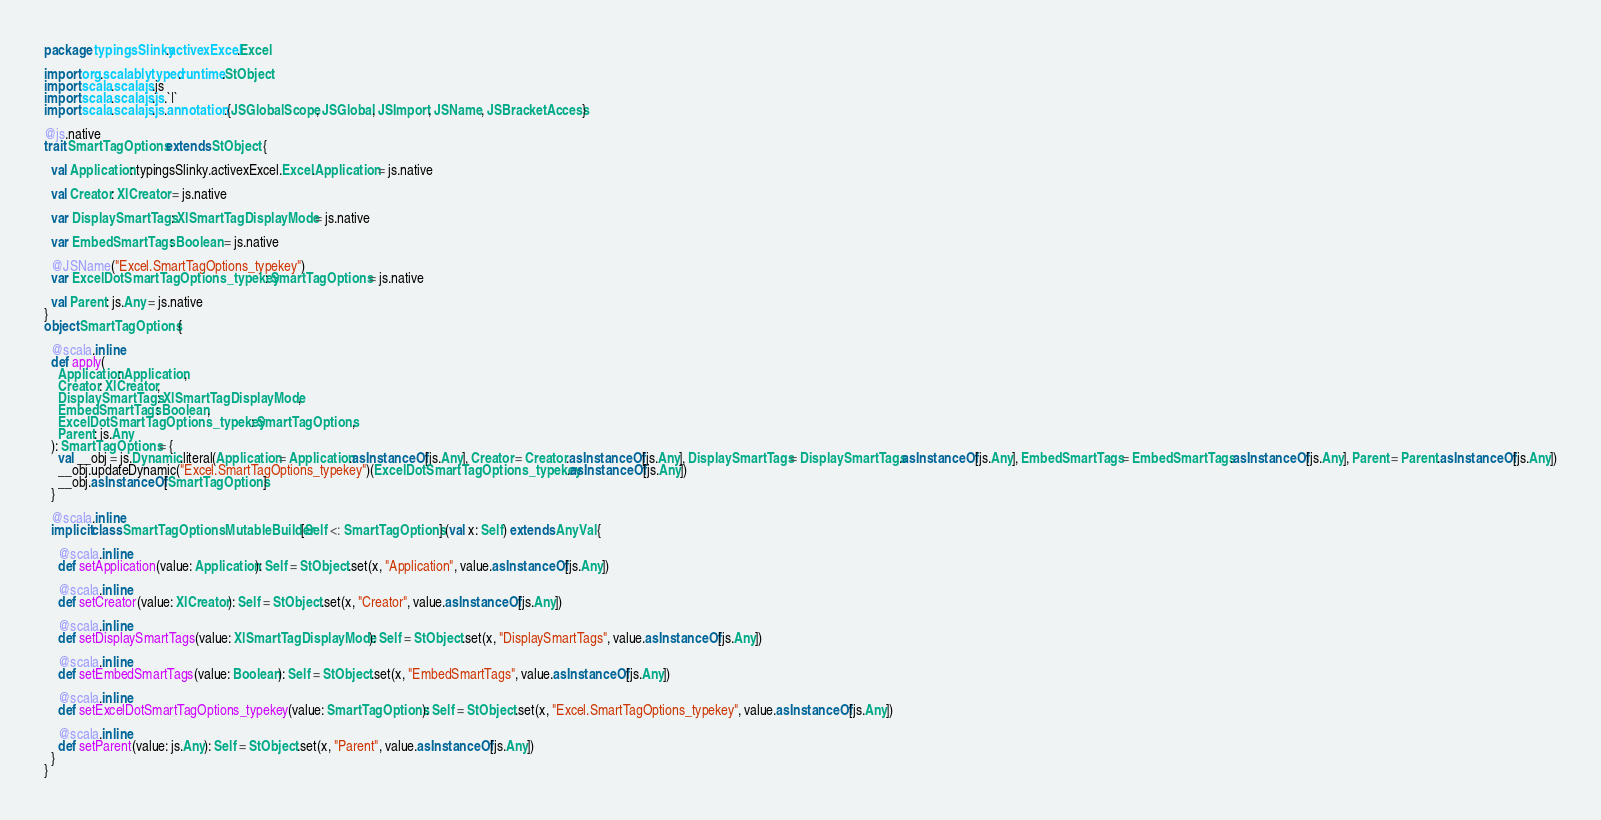Convert code to text. <code><loc_0><loc_0><loc_500><loc_500><_Scala_>package typingsSlinky.activexExcel.Excel

import org.scalablytyped.runtime.StObject
import scala.scalajs.js
import scala.scalajs.js.`|`
import scala.scalajs.js.annotation.{JSGlobalScope, JSGlobal, JSImport, JSName, JSBracketAccess}

@js.native
trait SmartTagOptions extends StObject {
  
  val Application: typingsSlinky.activexExcel.Excel.Application = js.native
  
  val Creator: XlCreator = js.native
  
  var DisplaySmartTags: XlSmartTagDisplayMode = js.native
  
  var EmbedSmartTags: Boolean = js.native
  
  @JSName("Excel.SmartTagOptions_typekey")
  var ExcelDotSmartTagOptions_typekey: SmartTagOptions = js.native
  
  val Parent: js.Any = js.native
}
object SmartTagOptions {
  
  @scala.inline
  def apply(
    Application: Application,
    Creator: XlCreator,
    DisplaySmartTags: XlSmartTagDisplayMode,
    EmbedSmartTags: Boolean,
    ExcelDotSmartTagOptions_typekey: SmartTagOptions,
    Parent: js.Any
  ): SmartTagOptions = {
    val __obj = js.Dynamic.literal(Application = Application.asInstanceOf[js.Any], Creator = Creator.asInstanceOf[js.Any], DisplaySmartTags = DisplaySmartTags.asInstanceOf[js.Any], EmbedSmartTags = EmbedSmartTags.asInstanceOf[js.Any], Parent = Parent.asInstanceOf[js.Any])
    __obj.updateDynamic("Excel.SmartTagOptions_typekey")(ExcelDotSmartTagOptions_typekey.asInstanceOf[js.Any])
    __obj.asInstanceOf[SmartTagOptions]
  }
  
  @scala.inline
  implicit class SmartTagOptionsMutableBuilder[Self <: SmartTagOptions] (val x: Self) extends AnyVal {
    
    @scala.inline
    def setApplication(value: Application): Self = StObject.set(x, "Application", value.asInstanceOf[js.Any])
    
    @scala.inline
    def setCreator(value: XlCreator): Self = StObject.set(x, "Creator", value.asInstanceOf[js.Any])
    
    @scala.inline
    def setDisplaySmartTags(value: XlSmartTagDisplayMode): Self = StObject.set(x, "DisplaySmartTags", value.asInstanceOf[js.Any])
    
    @scala.inline
    def setEmbedSmartTags(value: Boolean): Self = StObject.set(x, "EmbedSmartTags", value.asInstanceOf[js.Any])
    
    @scala.inline
    def setExcelDotSmartTagOptions_typekey(value: SmartTagOptions): Self = StObject.set(x, "Excel.SmartTagOptions_typekey", value.asInstanceOf[js.Any])
    
    @scala.inline
    def setParent(value: js.Any): Self = StObject.set(x, "Parent", value.asInstanceOf[js.Any])
  }
}
</code> 